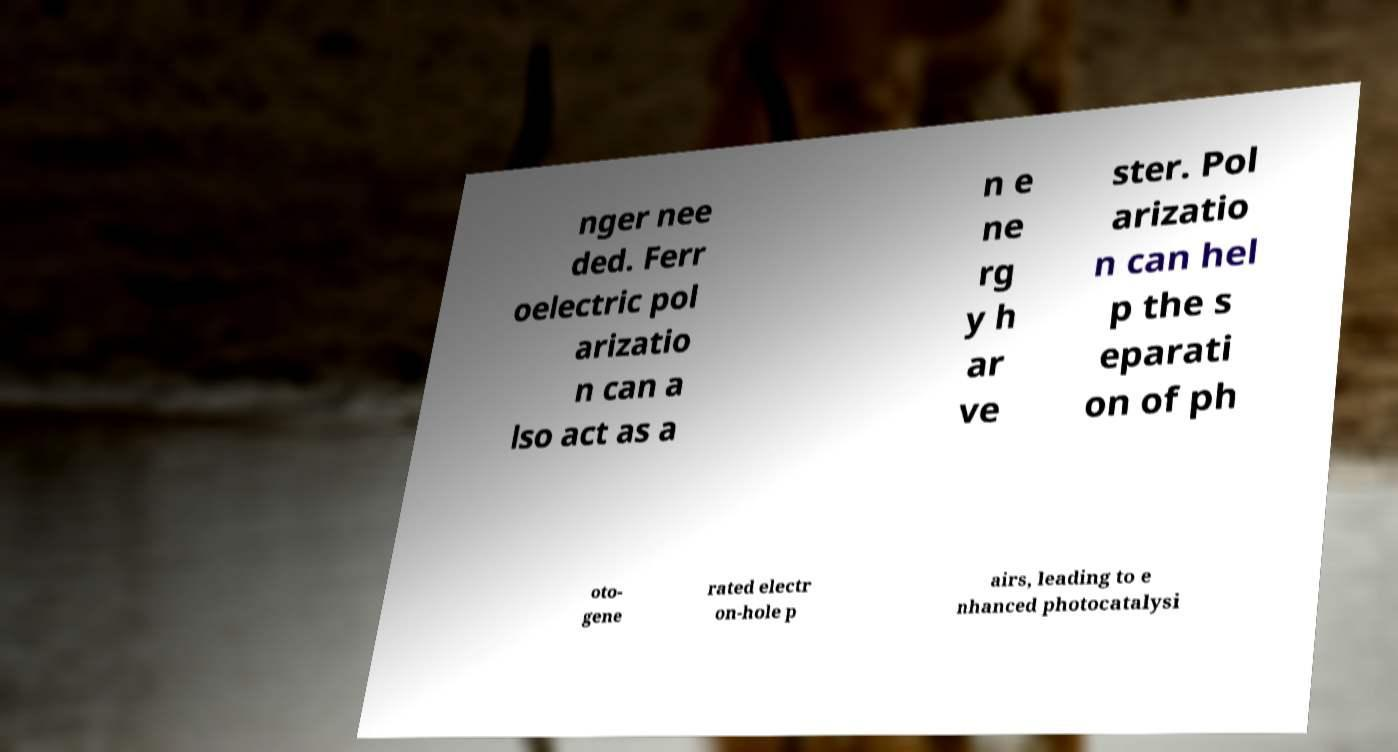What messages or text are displayed in this image? I need them in a readable, typed format. nger nee ded. Ferr oelectric pol arizatio n can a lso act as a n e ne rg y h ar ve ster. Pol arizatio n can hel p the s eparati on of ph oto- gene rated electr on-hole p airs, leading to e nhanced photocatalysi 